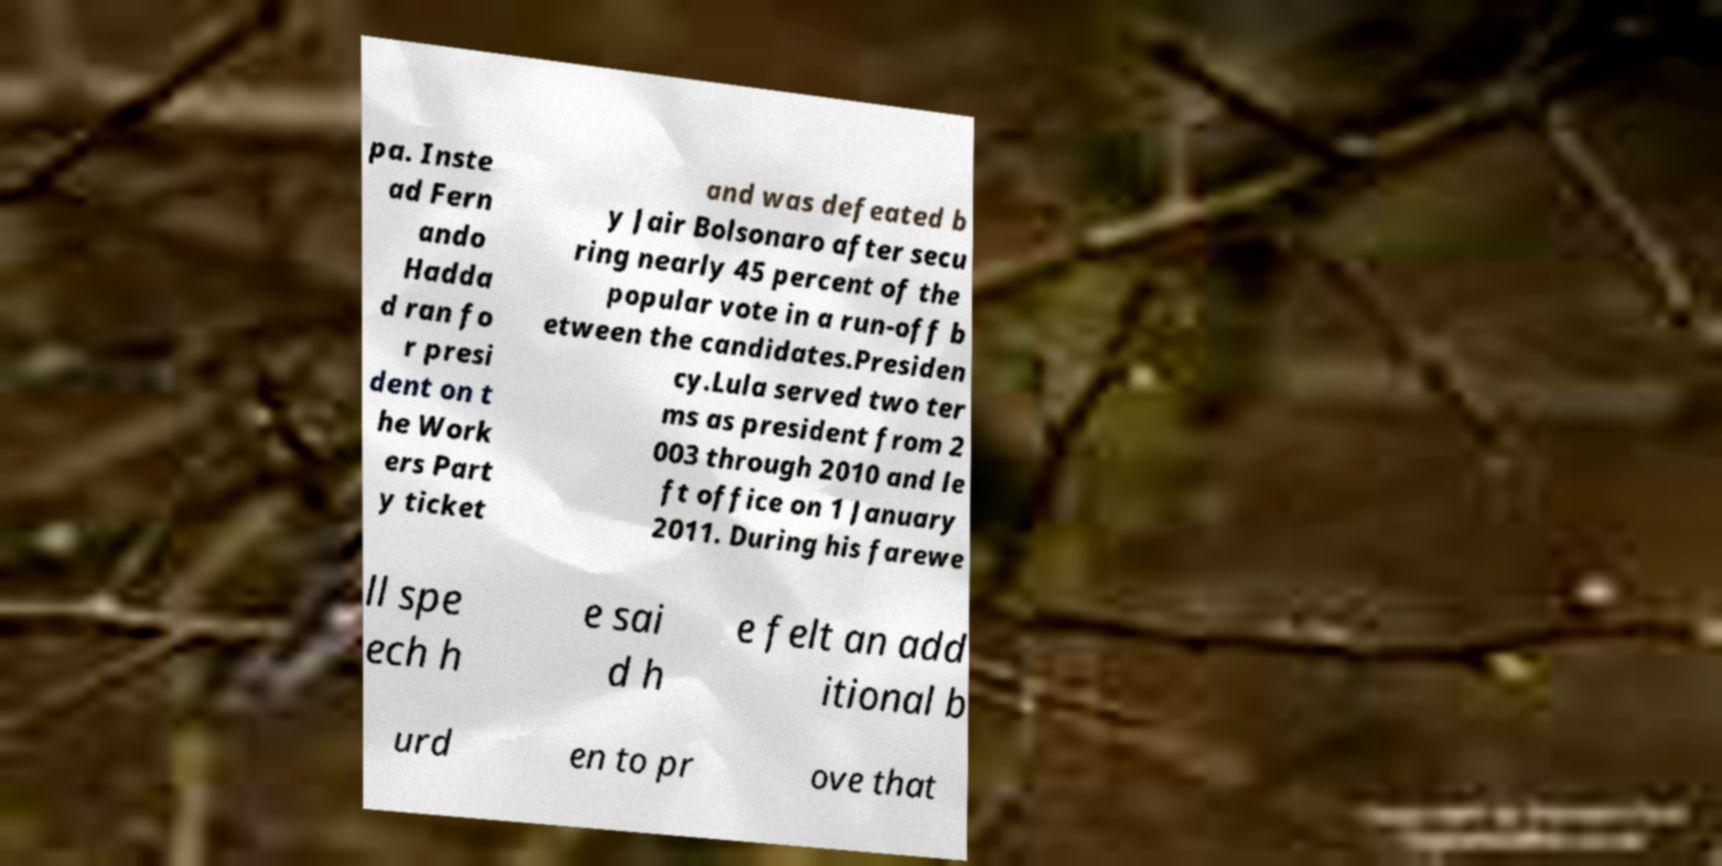I need the written content from this picture converted into text. Can you do that? pa. Inste ad Fern ando Hadda d ran fo r presi dent on t he Work ers Part y ticket and was defeated b y Jair Bolsonaro after secu ring nearly 45 percent of the popular vote in a run-off b etween the candidates.Presiden cy.Lula served two ter ms as president from 2 003 through 2010 and le ft office on 1 January 2011. During his farewe ll spe ech h e sai d h e felt an add itional b urd en to pr ove that 